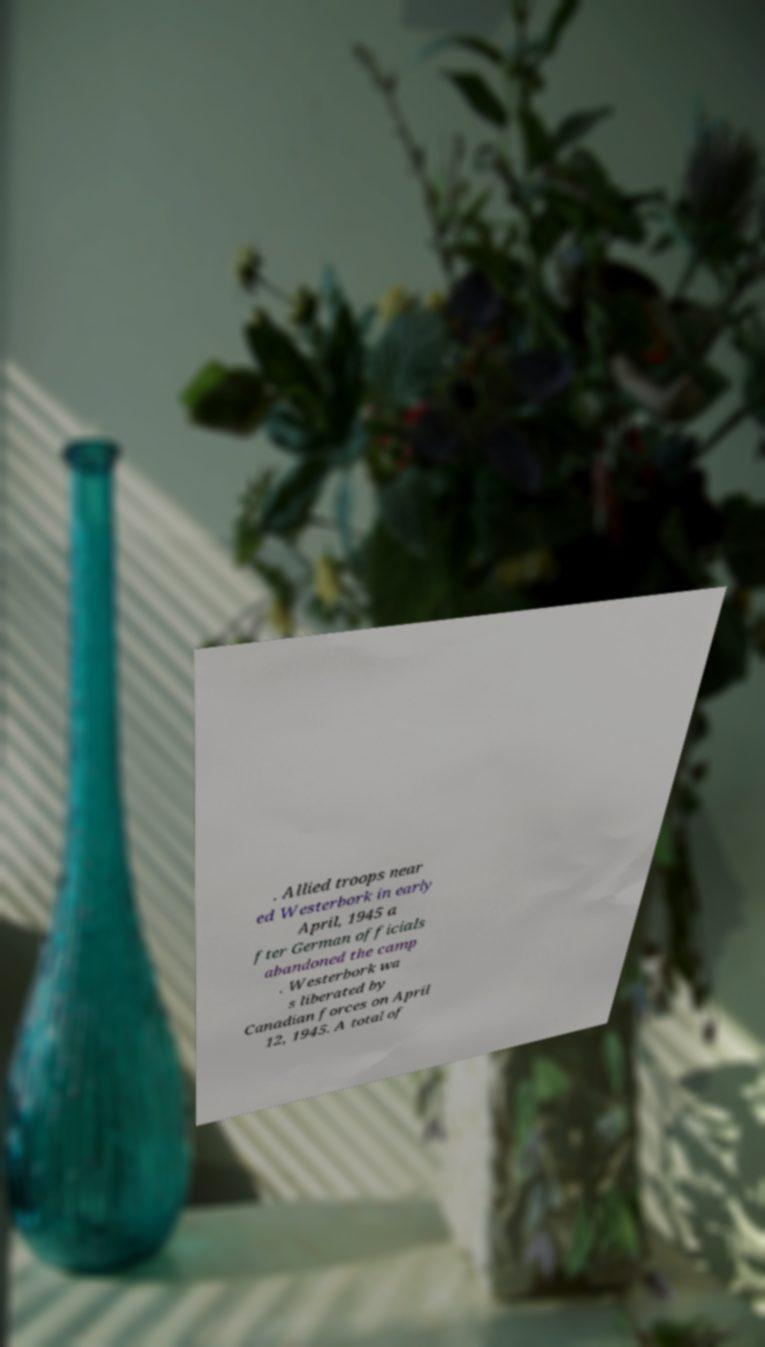For documentation purposes, I need the text within this image transcribed. Could you provide that? . Allied troops near ed Westerbork in early April, 1945 a fter German officials abandoned the camp . Westerbork wa s liberated by Canadian forces on April 12, 1945. A total of 